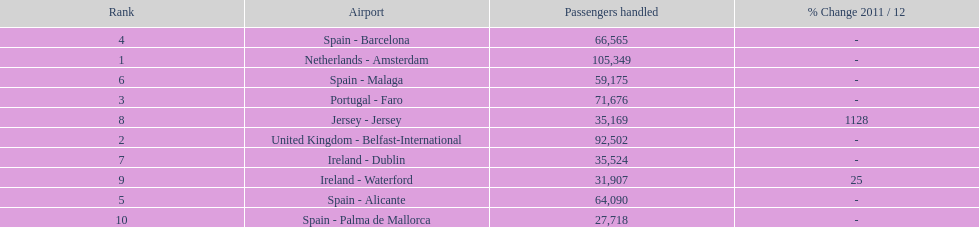Which airport has the least amount of passengers going through london southend airport? Spain - Palma de Mallorca. Would you be able to parse every entry in this table? {'header': ['Rank', 'Airport', 'Passengers handled', '% Change 2011 / 12'], 'rows': [['4', 'Spain - Barcelona', '66,565', '-'], ['1', 'Netherlands - Amsterdam', '105,349', '-'], ['6', 'Spain - Malaga', '59,175', '-'], ['3', 'Portugal - Faro', '71,676', '-'], ['8', 'Jersey - Jersey', '35,169', '1128'], ['2', 'United Kingdom - Belfast-International', '92,502', '-'], ['7', 'Ireland - Dublin', '35,524', '-'], ['9', 'Ireland - Waterford', '31,907', '25'], ['5', 'Spain - Alicante', '64,090', '-'], ['10', 'Spain - Palma de Mallorca', '27,718', '-']]} 